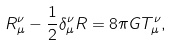Convert formula to latex. <formula><loc_0><loc_0><loc_500><loc_500>R _ { \mu } ^ { \nu } - \frac { 1 } { 2 } \delta _ { \mu } ^ { \nu } R = 8 \pi G T _ { \mu } ^ { \nu } ,</formula> 